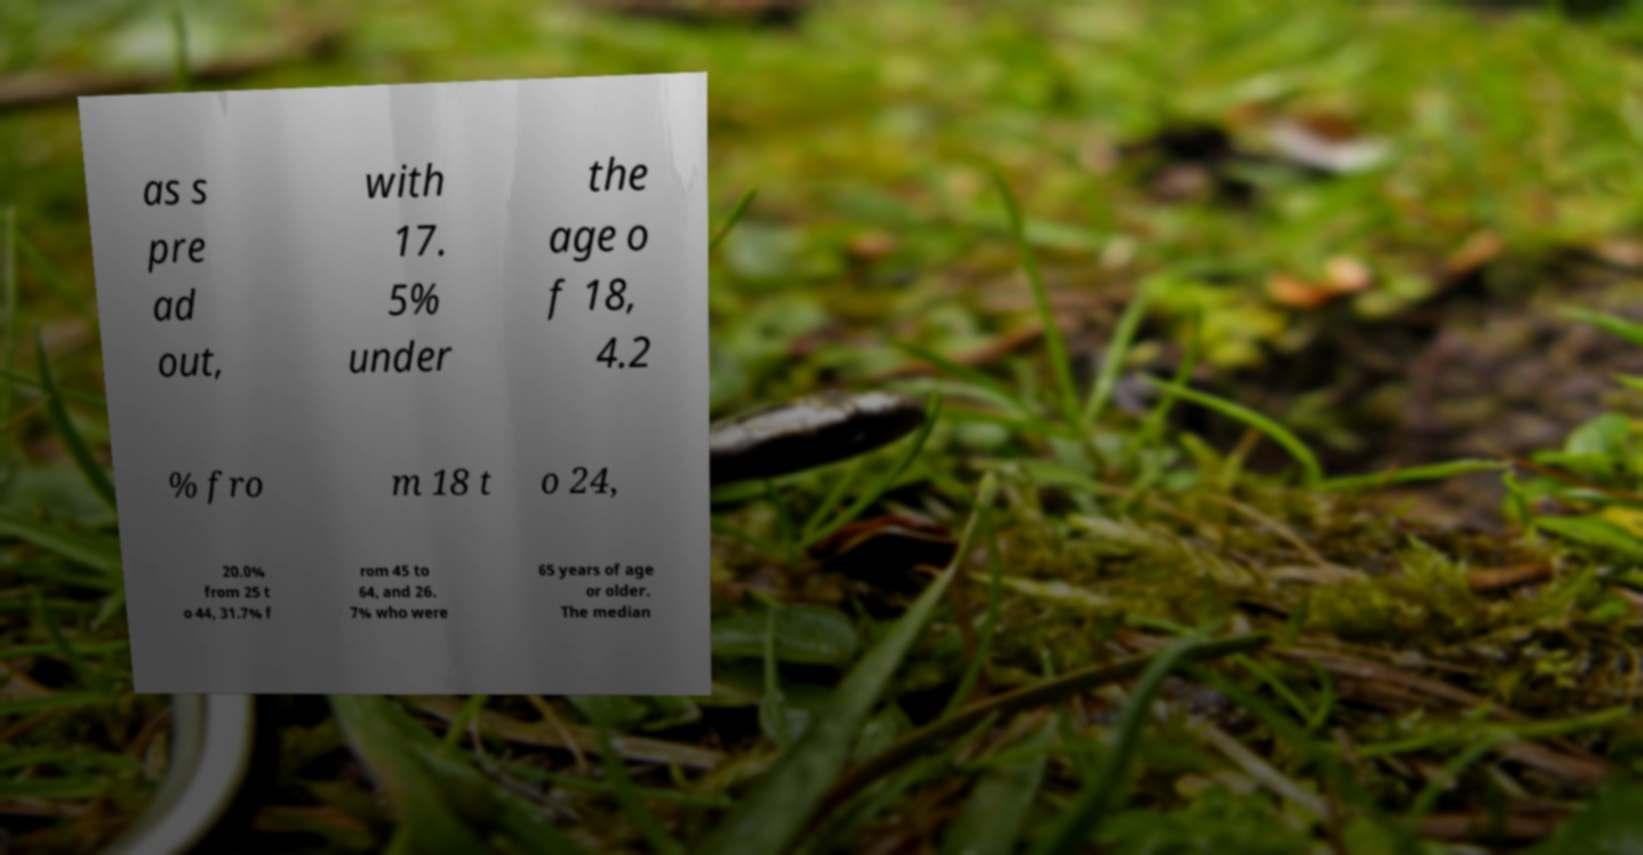Can you accurately transcribe the text from the provided image for me? as s pre ad out, with 17. 5% under the age o f 18, 4.2 % fro m 18 t o 24, 20.0% from 25 t o 44, 31.7% f rom 45 to 64, and 26. 7% who were 65 years of age or older. The median 